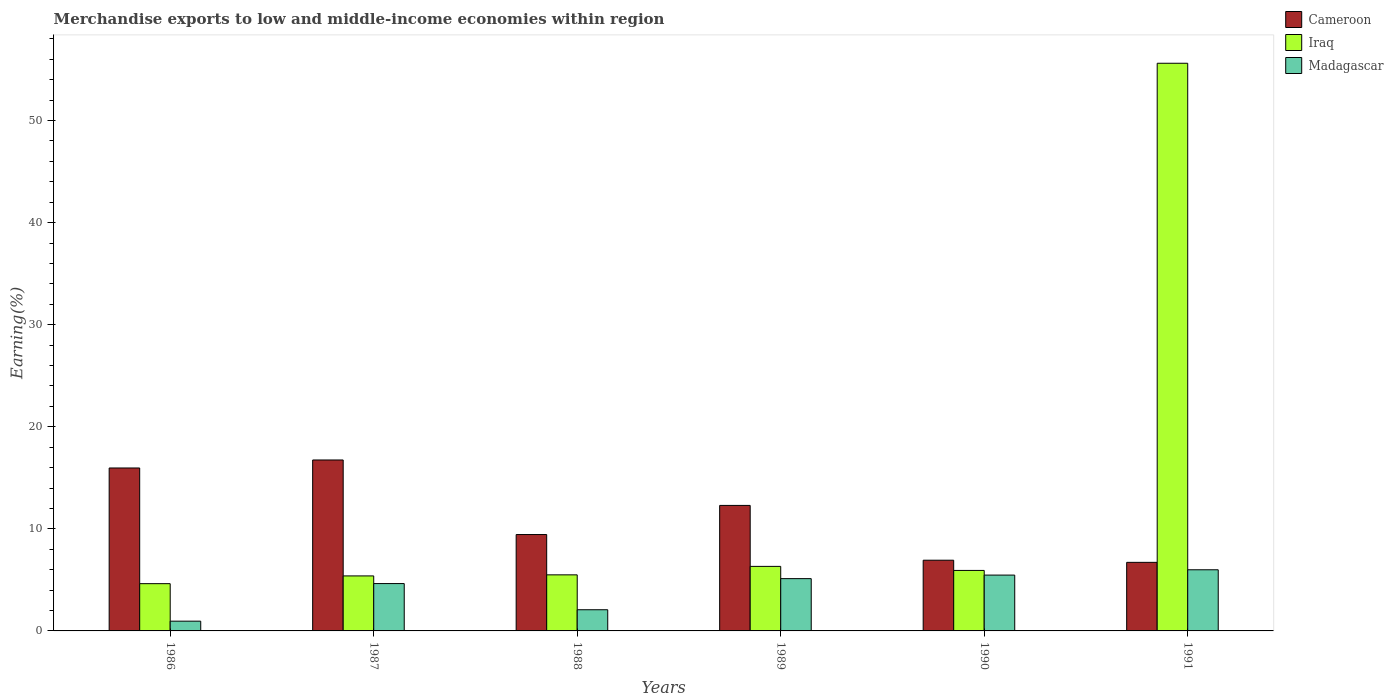How many different coloured bars are there?
Make the answer very short. 3. Are the number of bars per tick equal to the number of legend labels?
Your answer should be very brief. Yes. How many bars are there on the 1st tick from the left?
Give a very brief answer. 3. What is the label of the 5th group of bars from the left?
Give a very brief answer. 1990. In how many cases, is the number of bars for a given year not equal to the number of legend labels?
Ensure brevity in your answer.  0. What is the percentage of amount earned from merchandise exports in Cameroon in 1991?
Your response must be concise. 6.72. Across all years, what is the maximum percentage of amount earned from merchandise exports in Madagascar?
Your response must be concise. 5.99. Across all years, what is the minimum percentage of amount earned from merchandise exports in Iraq?
Ensure brevity in your answer.  4.63. In which year was the percentage of amount earned from merchandise exports in Madagascar minimum?
Provide a short and direct response. 1986. What is the total percentage of amount earned from merchandise exports in Madagascar in the graph?
Make the answer very short. 24.25. What is the difference between the percentage of amount earned from merchandise exports in Iraq in 1988 and that in 1989?
Give a very brief answer. -0.83. What is the difference between the percentage of amount earned from merchandise exports in Madagascar in 1989 and the percentage of amount earned from merchandise exports in Cameroon in 1990?
Keep it short and to the point. -1.8. What is the average percentage of amount earned from merchandise exports in Cameroon per year?
Provide a succinct answer. 11.35. In the year 1989, what is the difference between the percentage of amount earned from merchandise exports in Cameroon and percentage of amount earned from merchandise exports in Iraq?
Provide a short and direct response. 5.97. What is the ratio of the percentage of amount earned from merchandise exports in Iraq in 1987 to that in 1990?
Give a very brief answer. 0.91. Is the difference between the percentage of amount earned from merchandise exports in Cameroon in 1986 and 1991 greater than the difference between the percentage of amount earned from merchandise exports in Iraq in 1986 and 1991?
Provide a short and direct response. Yes. What is the difference between the highest and the second highest percentage of amount earned from merchandise exports in Madagascar?
Give a very brief answer. 0.52. What is the difference between the highest and the lowest percentage of amount earned from merchandise exports in Cameroon?
Your response must be concise. 10.03. In how many years, is the percentage of amount earned from merchandise exports in Iraq greater than the average percentage of amount earned from merchandise exports in Iraq taken over all years?
Provide a succinct answer. 1. What does the 2nd bar from the left in 1988 represents?
Your response must be concise. Iraq. What does the 1st bar from the right in 1990 represents?
Your answer should be very brief. Madagascar. Is it the case that in every year, the sum of the percentage of amount earned from merchandise exports in Cameroon and percentage of amount earned from merchandise exports in Iraq is greater than the percentage of amount earned from merchandise exports in Madagascar?
Ensure brevity in your answer.  Yes. How many bars are there?
Your response must be concise. 18. Are all the bars in the graph horizontal?
Keep it short and to the point. No. What is the difference between two consecutive major ticks on the Y-axis?
Keep it short and to the point. 10. Does the graph contain grids?
Provide a succinct answer. No. What is the title of the graph?
Your answer should be very brief. Merchandise exports to low and middle-income economies within region. What is the label or title of the X-axis?
Your answer should be compact. Years. What is the label or title of the Y-axis?
Offer a terse response. Earning(%). What is the Earning(%) of Cameroon in 1986?
Make the answer very short. 15.96. What is the Earning(%) of Iraq in 1986?
Offer a terse response. 4.63. What is the Earning(%) in Madagascar in 1986?
Give a very brief answer. 0.96. What is the Earning(%) of Cameroon in 1987?
Offer a terse response. 16.75. What is the Earning(%) in Iraq in 1987?
Keep it short and to the point. 5.39. What is the Earning(%) of Madagascar in 1987?
Your answer should be compact. 4.64. What is the Earning(%) in Cameroon in 1988?
Provide a short and direct response. 9.44. What is the Earning(%) in Iraq in 1988?
Offer a terse response. 5.49. What is the Earning(%) of Madagascar in 1988?
Provide a short and direct response. 2.07. What is the Earning(%) in Cameroon in 1989?
Your response must be concise. 12.3. What is the Earning(%) of Iraq in 1989?
Keep it short and to the point. 6.32. What is the Earning(%) of Madagascar in 1989?
Provide a short and direct response. 5.12. What is the Earning(%) in Cameroon in 1990?
Provide a short and direct response. 6.93. What is the Earning(%) in Iraq in 1990?
Your answer should be compact. 5.93. What is the Earning(%) of Madagascar in 1990?
Provide a succinct answer. 5.47. What is the Earning(%) in Cameroon in 1991?
Offer a very short reply. 6.72. What is the Earning(%) in Iraq in 1991?
Your answer should be compact. 55.61. What is the Earning(%) in Madagascar in 1991?
Keep it short and to the point. 5.99. Across all years, what is the maximum Earning(%) of Cameroon?
Give a very brief answer. 16.75. Across all years, what is the maximum Earning(%) of Iraq?
Your answer should be very brief. 55.61. Across all years, what is the maximum Earning(%) in Madagascar?
Your answer should be very brief. 5.99. Across all years, what is the minimum Earning(%) of Cameroon?
Your answer should be compact. 6.72. Across all years, what is the minimum Earning(%) of Iraq?
Offer a very short reply. 4.63. Across all years, what is the minimum Earning(%) of Madagascar?
Offer a very short reply. 0.96. What is the total Earning(%) of Cameroon in the graph?
Keep it short and to the point. 68.09. What is the total Earning(%) of Iraq in the graph?
Give a very brief answer. 83.37. What is the total Earning(%) of Madagascar in the graph?
Keep it short and to the point. 24.25. What is the difference between the Earning(%) of Cameroon in 1986 and that in 1987?
Your answer should be very brief. -0.78. What is the difference between the Earning(%) of Iraq in 1986 and that in 1987?
Provide a succinct answer. -0.76. What is the difference between the Earning(%) of Madagascar in 1986 and that in 1987?
Provide a short and direct response. -3.68. What is the difference between the Earning(%) in Cameroon in 1986 and that in 1988?
Your answer should be compact. 6.52. What is the difference between the Earning(%) of Iraq in 1986 and that in 1988?
Make the answer very short. -0.86. What is the difference between the Earning(%) in Madagascar in 1986 and that in 1988?
Your answer should be compact. -1.12. What is the difference between the Earning(%) in Cameroon in 1986 and that in 1989?
Give a very brief answer. 3.67. What is the difference between the Earning(%) of Iraq in 1986 and that in 1989?
Offer a terse response. -1.69. What is the difference between the Earning(%) of Madagascar in 1986 and that in 1989?
Your response must be concise. -4.17. What is the difference between the Earning(%) in Cameroon in 1986 and that in 1990?
Your answer should be very brief. 9.04. What is the difference between the Earning(%) of Iraq in 1986 and that in 1990?
Your answer should be compact. -1.3. What is the difference between the Earning(%) of Madagascar in 1986 and that in 1990?
Your response must be concise. -4.51. What is the difference between the Earning(%) in Cameroon in 1986 and that in 1991?
Offer a terse response. 9.24. What is the difference between the Earning(%) of Iraq in 1986 and that in 1991?
Keep it short and to the point. -50.98. What is the difference between the Earning(%) of Madagascar in 1986 and that in 1991?
Provide a short and direct response. -5.04. What is the difference between the Earning(%) of Cameroon in 1987 and that in 1988?
Offer a very short reply. 7.3. What is the difference between the Earning(%) in Iraq in 1987 and that in 1988?
Offer a very short reply. -0.1. What is the difference between the Earning(%) of Madagascar in 1987 and that in 1988?
Make the answer very short. 2.56. What is the difference between the Earning(%) of Cameroon in 1987 and that in 1989?
Make the answer very short. 4.45. What is the difference between the Earning(%) of Iraq in 1987 and that in 1989?
Your answer should be compact. -0.93. What is the difference between the Earning(%) of Madagascar in 1987 and that in 1989?
Your answer should be very brief. -0.48. What is the difference between the Earning(%) of Cameroon in 1987 and that in 1990?
Offer a terse response. 9.82. What is the difference between the Earning(%) in Iraq in 1987 and that in 1990?
Keep it short and to the point. -0.54. What is the difference between the Earning(%) of Madagascar in 1987 and that in 1990?
Offer a very short reply. -0.83. What is the difference between the Earning(%) of Cameroon in 1987 and that in 1991?
Your answer should be compact. 10.03. What is the difference between the Earning(%) of Iraq in 1987 and that in 1991?
Provide a succinct answer. -50.22. What is the difference between the Earning(%) of Madagascar in 1987 and that in 1991?
Your answer should be very brief. -1.35. What is the difference between the Earning(%) in Cameroon in 1988 and that in 1989?
Your answer should be compact. -2.85. What is the difference between the Earning(%) in Iraq in 1988 and that in 1989?
Provide a short and direct response. -0.83. What is the difference between the Earning(%) of Madagascar in 1988 and that in 1989?
Ensure brevity in your answer.  -3.05. What is the difference between the Earning(%) of Cameroon in 1988 and that in 1990?
Ensure brevity in your answer.  2.52. What is the difference between the Earning(%) in Iraq in 1988 and that in 1990?
Your answer should be compact. -0.43. What is the difference between the Earning(%) of Madagascar in 1988 and that in 1990?
Your answer should be very brief. -3.4. What is the difference between the Earning(%) in Cameroon in 1988 and that in 1991?
Ensure brevity in your answer.  2.72. What is the difference between the Earning(%) in Iraq in 1988 and that in 1991?
Your answer should be very brief. -50.12. What is the difference between the Earning(%) in Madagascar in 1988 and that in 1991?
Ensure brevity in your answer.  -3.92. What is the difference between the Earning(%) of Cameroon in 1989 and that in 1990?
Your answer should be compact. 5.37. What is the difference between the Earning(%) in Iraq in 1989 and that in 1990?
Offer a terse response. 0.4. What is the difference between the Earning(%) of Madagascar in 1989 and that in 1990?
Offer a terse response. -0.35. What is the difference between the Earning(%) in Cameroon in 1989 and that in 1991?
Offer a very short reply. 5.58. What is the difference between the Earning(%) in Iraq in 1989 and that in 1991?
Provide a short and direct response. -49.29. What is the difference between the Earning(%) of Madagascar in 1989 and that in 1991?
Give a very brief answer. -0.87. What is the difference between the Earning(%) in Cameroon in 1990 and that in 1991?
Provide a succinct answer. 0.21. What is the difference between the Earning(%) of Iraq in 1990 and that in 1991?
Provide a succinct answer. -49.69. What is the difference between the Earning(%) in Madagascar in 1990 and that in 1991?
Offer a very short reply. -0.52. What is the difference between the Earning(%) in Cameroon in 1986 and the Earning(%) in Iraq in 1987?
Your answer should be very brief. 10.57. What is the difference between the Earning(%) of Cameroon in 1986 and the Earning(%) of Madagascar in 1987?
Keep it short and to the point. 11.32. What is the difference between the Earning(%) of Iraq in 1986 and the Earning(%) of Madagascar in 1987?
Your response must be concise. -0.01. What is the difference between the Earning(%) in Cameroon in 1986 and the Earning(%) in Iraq in 1988?
Offer a very short reply. 10.47. What is the difference between the Earning(%) in Cameroon in 1986 and the Earning(%) in Madagascar in 1988?
Provide a succinct answer. 13.89. What is the difference between the Earning(%) of Iraq in 1986 and the Earning(%) of Madagascar in 1988?
Offer a terse response. 2.56. What is the difference between the Earning(%) in Cameroon in 1986 and the Earning(%) in Iraq in 1989?
Keep it short and to the point. 9.64. What is the difference between the Earning(%) in Cameroon in 1986 and the Earning(%) in Madagascar in 1989?
Your answer should be compact. 10.84. What is the difference between the Earning(%) in Iraq in 1986 and the Earning(%) in Madagascar in 1989?
Ensure brevity in your answer.  -0.49. What is the difference between the Earning(%) of Cameroon in 1986 and the Earning(%) of Iraq in 1990?
Give a very brief answer. 10.04. What is the difference between the Earning(%) of Cameroon in 1986 and the Earning(%) of Madagascar in 1990?
Your response must be concise. 10.49. What is the difference between the Earning(%) in Iraq in 1986 and the Earning(%) in Madagascar in 1990?
Give a very brief answer. -0.84. What is the difference between the Earning(%) of Cameroon in 1986 and the Earning(%) of Iraq in 1991?
Your answer should be compact. -39.65. What is the difference between the Earning(%) of Cameroon in 1986 and the Earning(%) of Madagascar in 1991?
Offer a terse response. 9.97. What is the difference between the Earning(%) of Iraq in 1986 and the Earning(%) of Madagascar in 1991?
Your answer should be compact. -1.36. What is the difference between the Earning(%) of Cameroon in 1987 and the Earning(%) of Iraq in 1988?
Your answer should be compact. 11.25. What is the difference between the Earning(%) of Cameroon in 1987 and the Earning(%) of Madagascar in 1988?
Offer a very short reply. 14.67. What is the difference between the Earning(%) of Iraq in 1987 and the Earning(%) of Madagascar in 1988?
Keep it short and to the point. 3.31. What is the difference between the Earning(%) in Cameroon in 1987 and the Earning(%) in Iraq in 1989?
Your answer should be very brief. 10.42. What is the difference between the Earning(%) of Cameroon in 1987 and the Earning(%) of Madagascar in 1989?
Your answer should be compact. 11.62. What is the difference between the Earning(%) of Iraq in 1987 and the Earning(%) of Madagascar in 1989?
Give a very brief answer. 0.27. What is the difference between the Earning(%) of Cameroon in 1987 and the Earning(%) of Iraq in 1990?
Provide a short and direct response. 10.82. What is the difference between the Earning(%) of Cameroon in 1987 and the Earning(%) of Madagascar in 1990?
Provide a short and direct response. 11.28. What is the difference between the Earning(%) of Iraq in 1987 and the Earning(%) of Madagascar in 1990?
Offer a terse response. -0.08. What is the difference between the Earning(%) of Cameroon in 1987 and the Earning(%) of Iraq in 1991?
Keep it short and to the point. -38.87. What is the difference between the Earning(%) in Cameroon in 1987 and the Earning(%) in Madagascar in 1991?
Provide a short and direct response. 10.76. What is the difference between the Earning(%) in Iraq in 1987 and the Earning(%) in Madagascar in 1991?
Make the answer very short. -0.6. What is the difference between the Earning(%) of Cameroon in 1988 and the Earning(%) of Iraq in 1989?
Ensure brevity in your answer.  3.12. What is the difference between the Earning(%) of Cameroon in 1988 and the Earning(%) of Madagascar in 1989?
Make the answer very short. 4.32. What is the difference between the Earning(%) of Iraq in 1988 and the Earning(%) of Madagascar in 1989?
Ensure brevity in your answer.  0.37. What is the difference between the Earning(%) in Cameroon in 1988 and the Earning(%) in Iraq in 1990?
Provide a short and direct response. 3.52. What is the difference between the Earning(%) of Cameroon in 1988 and the Earning(%) of Madagascar in 1990?
Your answer should be very brief. 3.97. What is the difference between the Earning(%) in Iraq in 1988 and the Earning(%) in Madagascar in 1990?
Give a very brief answer. 0.02. What is the difference between the Earning(%) of Cameroon in 1988 and the Earning(%) of Iraq in 1991?
Offer a very short reply. -46.17. What is the difference between the Earning(%) in Cameroon in 1988 and the Earning(%) in Madagascar in 1991?
Provide a short and direct response. 3.45. What is the difference between the Earning(%) in Iraq in 1988 and the Earning(%) in Madagascar in 1991?
Keep it short and to the point. -0.5. What is the difference between the Earning(%) in Cameroon in 1989 and the Earning(%) in Iraq in 1990?
Offer a very short reply. 6.37. What is the difference between the Earning(%) in Cameroon in 1989 and the Earning(%) in Madagascar in 1990?
Provide a short and direct response. 6.83. What is the difference between the Earning(%) in Iraq in 1989 and the Earning(%) in Madagascar in 1990?
Your answer should be compact. 0.85. What is the difference between the Earning(%) in Cameroon in 1989 and the Earning(%) in Iraq in 1991?
Offer a very short reply. -43.32. What is the difference between the Earning(%) of Cameroon in 1989 and the Earning(%) of Madagascar in 1991?
Keep it short and to the point. 6.31. What is the difference between the Earning(%) in Iraq in 1989 and the Earning(%) in Madagascar in 1991?
Provide a succinct answer. 0.33. What is the difference between the Earning(%) in Cameroon in 1990 and the Earning(%) in Iraq in 1991?
Provide a succinct answer. -48.69. What is the difference between the Earning(%) in Cameroon in 1990 and the Earning(%) in Madagascar in 1991?
Your answer should be compact. 0.94. What is the difference between the Earning(%) in Iraq in 1990 and the Earning(%) in Madagascar in 1991?
Offer a terse response. -0.06. What is the average Earning(%) of Cameroon per year?
Your answer should be compact. 11.35. What is the average Earning(%) in Iraq per year?
Provide a short and direct response. 13.9. What is the average Earning(%) in Madagascar per year?
Your response must be concise. 4.04. In the year 1986, what is the difference between the Earning(%) of Cameroon and Earning(%) of Iraq?
Keep it short and to the point. 11.33. In the year 1986, what is the difference between the Earning(%) in Cameroon and Earning(%) in Madagascar?
Provide a succinct answer. 15.01. In the year 1986, what is the difference between the Earning(%) of Iraq and Earning(%) of Madagascar?
Your response must be concise. 3.67. In the year 1987, what is the difference between the Earning(%) of Cameroon and Earning(%) of Iraq?
Offer a terse response. 11.36. In the year 1987, what is the difference between the Earning(%) in Cameroon and Earning(%) in Madagascar?
Keep it short and to the point. 12.11. In the year 1988, what is the difference between the Earning(%) in Cameroon and Earning(%) in Iraq?
Keep it short and to the point. 3.95. In the year 1988, what is the difference between the Earning(%) in Cameroon and Earning(%) in Madagascar?
Keep it short and to the point. 7.37. In the year 1988, what is the difference between the Earning(%) in Iraq and Earning(%) in Madagascar?
Make the answer very short. 3.42. In the year 1989, what is the difference between the Earning(%) of Cameroon and Earning(%) of Iraq?
Provide a succinct answer. 5.97. In the year 1989, what is the difference between the Earning(%) in Cameroon and Earning(%) in Madagascar?
Make the answer very short. 7.17. In the year 1989, what is the difference between the Earning(%) of Iraq and Earning(%) of Madagascar?
Make the answer very short. 1.2. In the year 1990, what is the difference between the Earning(%) in Cameroon and Earning(%) in Iraq?
Your answer should be compact. 1. In the year 1990, what is the difference between the Earning(%) of Cameroon and Earning(%) of Madagascar?
Give a very brief answer. 1.46. In the year 1990, what is the difference between the Earning(%) in Iraq and Earning(%) in Madagascar?
Offer a terse response. 0.46. In the year 1991, what is the difference between the Earning(%) of Cameroon and Earning(%) of Iraq?
Your answer should be compact. -48.89. In the year 1991, what is the difference between the Earning(%) in Cameroon and Earning(%) in Madagascar?
Keep it short and to the point. 0.73. In the year 1991, what is the difference between the Earning(%) in Iraq and Earning(%) in Madagascar?
Your response must be concise. 49.62. What is the ratio of the Earning(%) of Cameroon in 1986 to that in 1987?
Your answer should be very brief. 0.95. What is the ratio of the Earning(%) in Iraq in 1986 to that in 1987?
Your response must be concise. 0.86. What is the ratio of the Earning(%) in Madagascar in 1986 to that in 1987?
Provide a succinct answer. 0.21. What is the ratio of the Earning(%) of Cameroon in 1986 to that in 1988?
Give a very brief answer. 1.69. What is the ratio of the Earning(%) of Iraq in 1986 to that in 1988?
Provide a short and direct response. 0.84. What is the ratio of the Earning(%) in Madagascar in 1986 to that in 1988?
Provide a short and direct response. 0.46. What is the ratio of the Earning(%) of Cameroon in 1986 to that in 1989?
Keep it short and to the point. 1.3. What is the ratio of the Earning(%) of Iraq in 1986 to that in 1989?
Your answer should be compact. 0.73. What is the ratio of the Earning(%) in Madagascar in 1986 to that in 1989?
Offer a very short reply. 0.19. What is the ratio of the Earning(%) in Cameroon in 1986 to that in 1990?
Make the answer very short. 2.3. What is the ratio of the Earning(%) of Iraq in 1986 to that in 1990?
Your response must be concise. 0.78. What is the ratio of the Earning(%) of Madagascar in 1986 to that in 1990?
Provide a succinct answer. 0.17. What is the ratio of the Earning(%) in Cameroon in 1986 to that in 1991?
Keep it short and to the point. 2.38. What is the ratio of the Earning(%) in Iraq in 1986 to that in 1991?
Your answer should be very brief. 0.08. What is the ratio of the Earning(%) in Madagascar in 1986 to that in 1991?
Provide a short and direct response. 0.16. What is the ratio of the Earning(%) in Cameroon in 1987 to that in 1988?
Give a very brief answer. 1.77. What is the ratio of the Earning(%) in Iraq in 1987 to that in 1988?
Your answer should be very brief. 0.98. What is the ratio of the Earning(%) in Madagascar in 1987 to that in 1988?
Your answer should be compact. 2.24. What is the ratio of the Earning(%) in Cameroon in 1987 to that in 1989?
Make the answer very short. 1.36. What is the ratio of the Earning(%) of Iraq in 1987 to that in 1989?
Provide a succinct answer. 0.85. What is the ratio of the Earning(%) of Madagascar in 1987 to that in 1989?
Give a very brief answer. 0.91. What is the ratio of the Earning(%) in Cameroon in 1987 to that in 1990?
Give a very brief answer. 2.42. What is the ratio of the Earning(%) of Iraq in 1987 to that in 1990?
Make the answer very short. 0.91. What is the ratio of the Earning(%) in Madagascar in 1987 to that in 1990?
Provide a short and direct response. 0.85. What is the ratio of the Earning(%) in Cameroon in 1987 to that in 1991?
Your answer should be compact. 2.49. What is the ratio of the Earning(%) of Iraq in 1987 to that in 1991?
Offer a very short reply. 0.1. What is the ratio of the Earning(%) in Madagascar in 1987 to that in 1991?
Make the answer very short. 0.77. What is the ratio of the Earning(%) in Cameroon in 1988 to that in 1989?
Keep it short and to the point. 0.77. What is the ratio of the Earning(%) of Iraq in 1988 to that in 1989?
Give a very brief answer. 0.87. What is the ratio of the Earning(%) of Madagascar in 1988 to that in 1989?
Offer a very short reply. 0.41. What is the ratio of the Earning(%) in Cameroon in 1988 to that in 1990?
Make the answer very short. 1.36. What is the ratio of the Earning(%) of Iraq in 1988 to that in 1990?
Offer a very short reply. 0.93. What is the ratio of the Earning(%) in Madagascar in 1988 to that in 1990?
Give a very brief answer. 0.38. What is the ratio of the Earning(%) in Cameroon in 1988 to that in 1991?
Your answer should be very brief. 1.41. What is the ratio of the Earning(%) in Iraq in 1988 to that in 1991?
Ensure brevity in your answer.  0.1. What is the ratio of the Earning(%) of Madagascar in 1988 to that in 1991?
Give a very brief answer. 0.35. What is the ratio of the Earning(%) in Cameroon in 1989 to that in 1990?
Provide a short and direct response. 1.78. What is the ratio of the Earning(%) in Iraq in 1989 to that in 1990?
Keep it short and to the point. 1.07. What is the ratio of the Earning(%) of Madagascar in 1989 to that in 1990?
Ensure brevity in your answer.  0.94. What is the ratio of the Earning(%) in Cameroon in 1989 to that in 1991?
Offer a terse response. 1.83. What is the ratio of the Earning(%) in Iraq in 1989 to that in 1991?
Ensure brevity in your answer.  0.11. What is the ratio of the Earning(%) in Madagascar in 1989 to that in 1991?
Your response must be concise. 0.86. What is the ratio of the Earning(%) in Cameroon in 1990 to that in 1991?
Offer a terse response. 1.03. What is the ratio of the Earning(%) of Iraq in 1990 to that in 1991?
Make the answer very short. 0.11. What is the ratio of the Earning(%) of Madagascar in 1990 to that in 1991?
Your response must be concise. 0.91. What is the difference between the highest and the second highest Earning(%) of Cameroon?
Your response must be concise. 0.78. What is the difference between the highest and the second highest Earning(%) in Iraq?
Ensure brevity in your answer.  49.29. What is the difference between the highest and the second highest Earning(%) of Madagascar?
Provide a succinct answer. 0.52. What is the difference between the highest and the lowest Earning(%) of Cameroon?
Provide a short and direct response. 10.03. What is the difference between the highest and the lowest Earning(%) of Iraq?
Your response must be concise. 50.98. What is the difference between the highest and the lowest Earning(%) in Madagascar?
Keep it short and to the point. 5.04. 